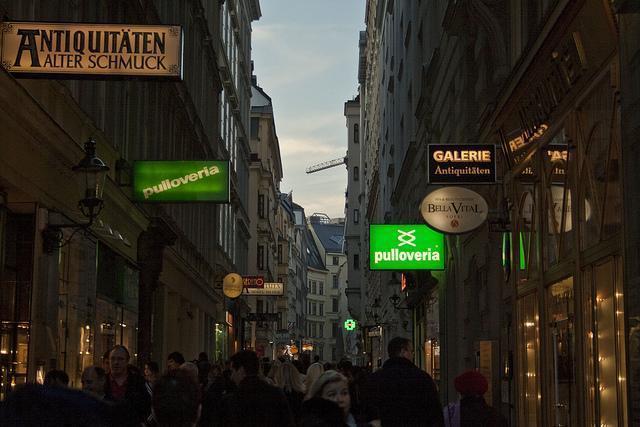Where is Pulloveria based?
Select the accurate answer and provide explanation: 'Answer: answer
Rationale: rationale.'
Options: Hamburg, vienna, new york, toronto. Answer: vienna.
Rationale: Pulloveria is in vienna. 